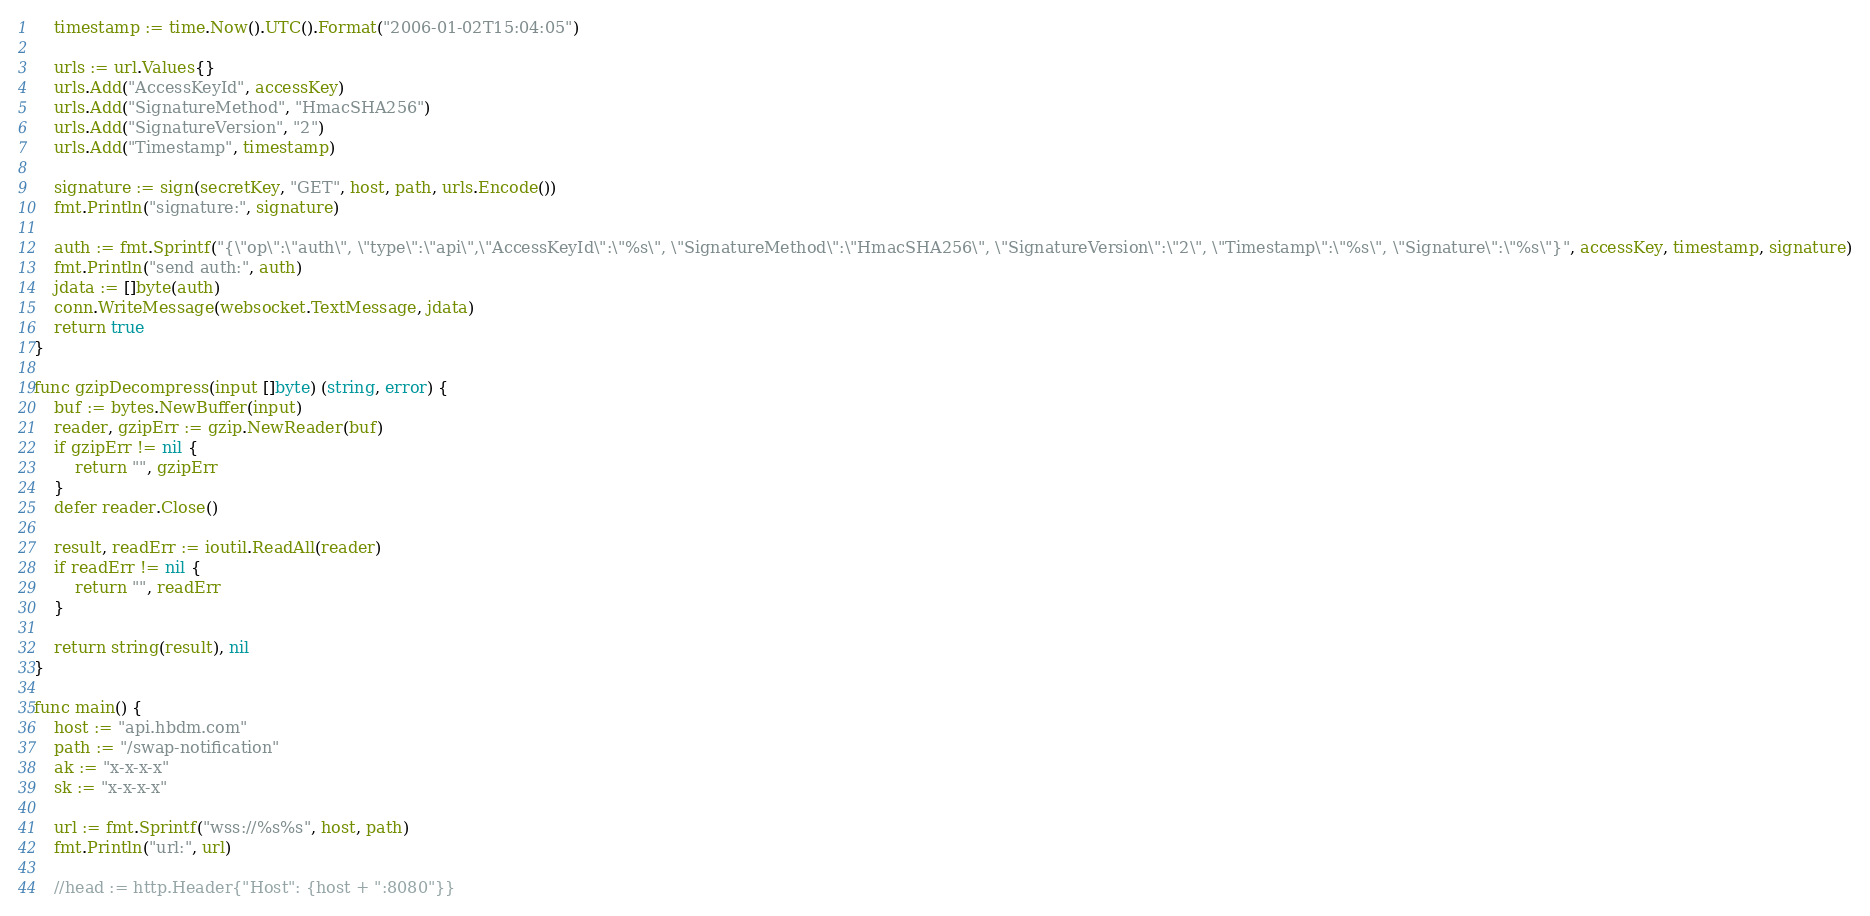Convert code to text. <code><loc_0><loc_0><loc_500><loc_500><_Go_>	timestamp := time.Now().UTC().Format("2006-01-02T15:04:05")

	urls := url.Values{}
	urls.Add("AccessKeyId", accessKey)
	urls.Add("SignatureMethod", "HmacSHA256")
	urls.Add("SignatureVersion", "2")
	urls.Add("Timestamp", timestamp)

	signature := sign(secretKey, "GET", host, path, urls.Encode())
	fmt.Println("signature:", signature)

	auth := fmt.Sprintf("{\"op\":\"auth\", \"type\":\"api\",\"AccessKeyId\":\"%s\", \"SignatureMethod\":\"HmacSHA256\", \"SignatureVersion\":\"2\", \"Timestamp\":\"%s\", \"Signature\":\"%s\"}", accessKey, timestamp, signature)
	fmt.Println("send auth:", auth)
	jdata := []byte(auth)
	conn.WriteMessage(websocket.TextMessage, jdata)
	return true
}

func gzipDecompress(input []byte) (string, error) {
	buf := bytes.NewBuffer(input)
	reader, gzipErr := gzip.NewReader(buf)
	if gzipErr != nil {
		return "", gzipErr
	}
	defer reader.Close()

	result, readErr := ioutil.ReadAll(reader)
	if readErr != nil {
		return "", readErr
	}

	return string(result), nil
}

func main() {
	host := "api.hbdm.com"
	path := "/swap-notification"
	ak := "x-x-x-x"
	sk := "x-x-x-x"

	url := fmt.Sprintf("wss://%s%s", host, path)
	fmt.Println("url:", url)

	//head := http.Header{"Host": {host + ":8080"}}</code> 